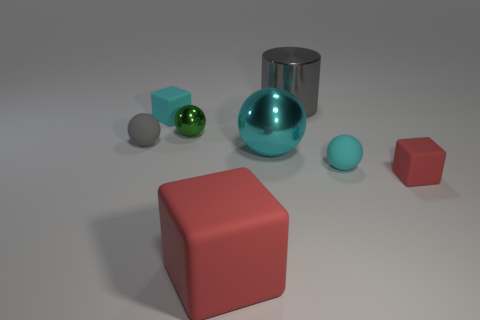What number of things are either red rubber cubes that are right of the big gray cylinder or blue spheres?
Make the answer very short. 1. Are there more gray matte spheres behind the tiny red cube than small red rubber objects that are behind the small cyan ball?
Keep it short and to the point. Yes. Are the small gray sphere and the large cyan ball made of the same material?
Keep it short and to the point. No. What shape is the large object that is both in front of the cyan block and on the right side of the big red object?
Your answer should be compact. Sphere. There is a gray thing that is the same material as the tiny red cube; what is its shape?
Your answer should be compact. Sphere. Are there any big rubber cylinders?
Offer a terse response. No. There is a cylinder behind the gray matte object; is there a gray sphere in front of it?
Keep it short and to the point. Yes. What is the material of the tiny cyan object that is the same shape as the green thing?
Provide a succinct answer. Rubber. Is the number of red cubes greater than the number of cyan metal balls?
Your answer should be compact. Yes. There is a big block; does it have the same color as the tiny cube that is in front of the gray matte sphere?
Give a very brief answer. Yes. 